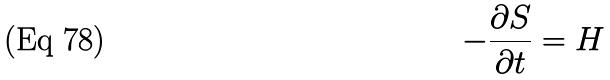<formula> <loc_0><loc_0><loc_500><loc_500>- \frac { \partial S } { \partial t } = H</formula> 